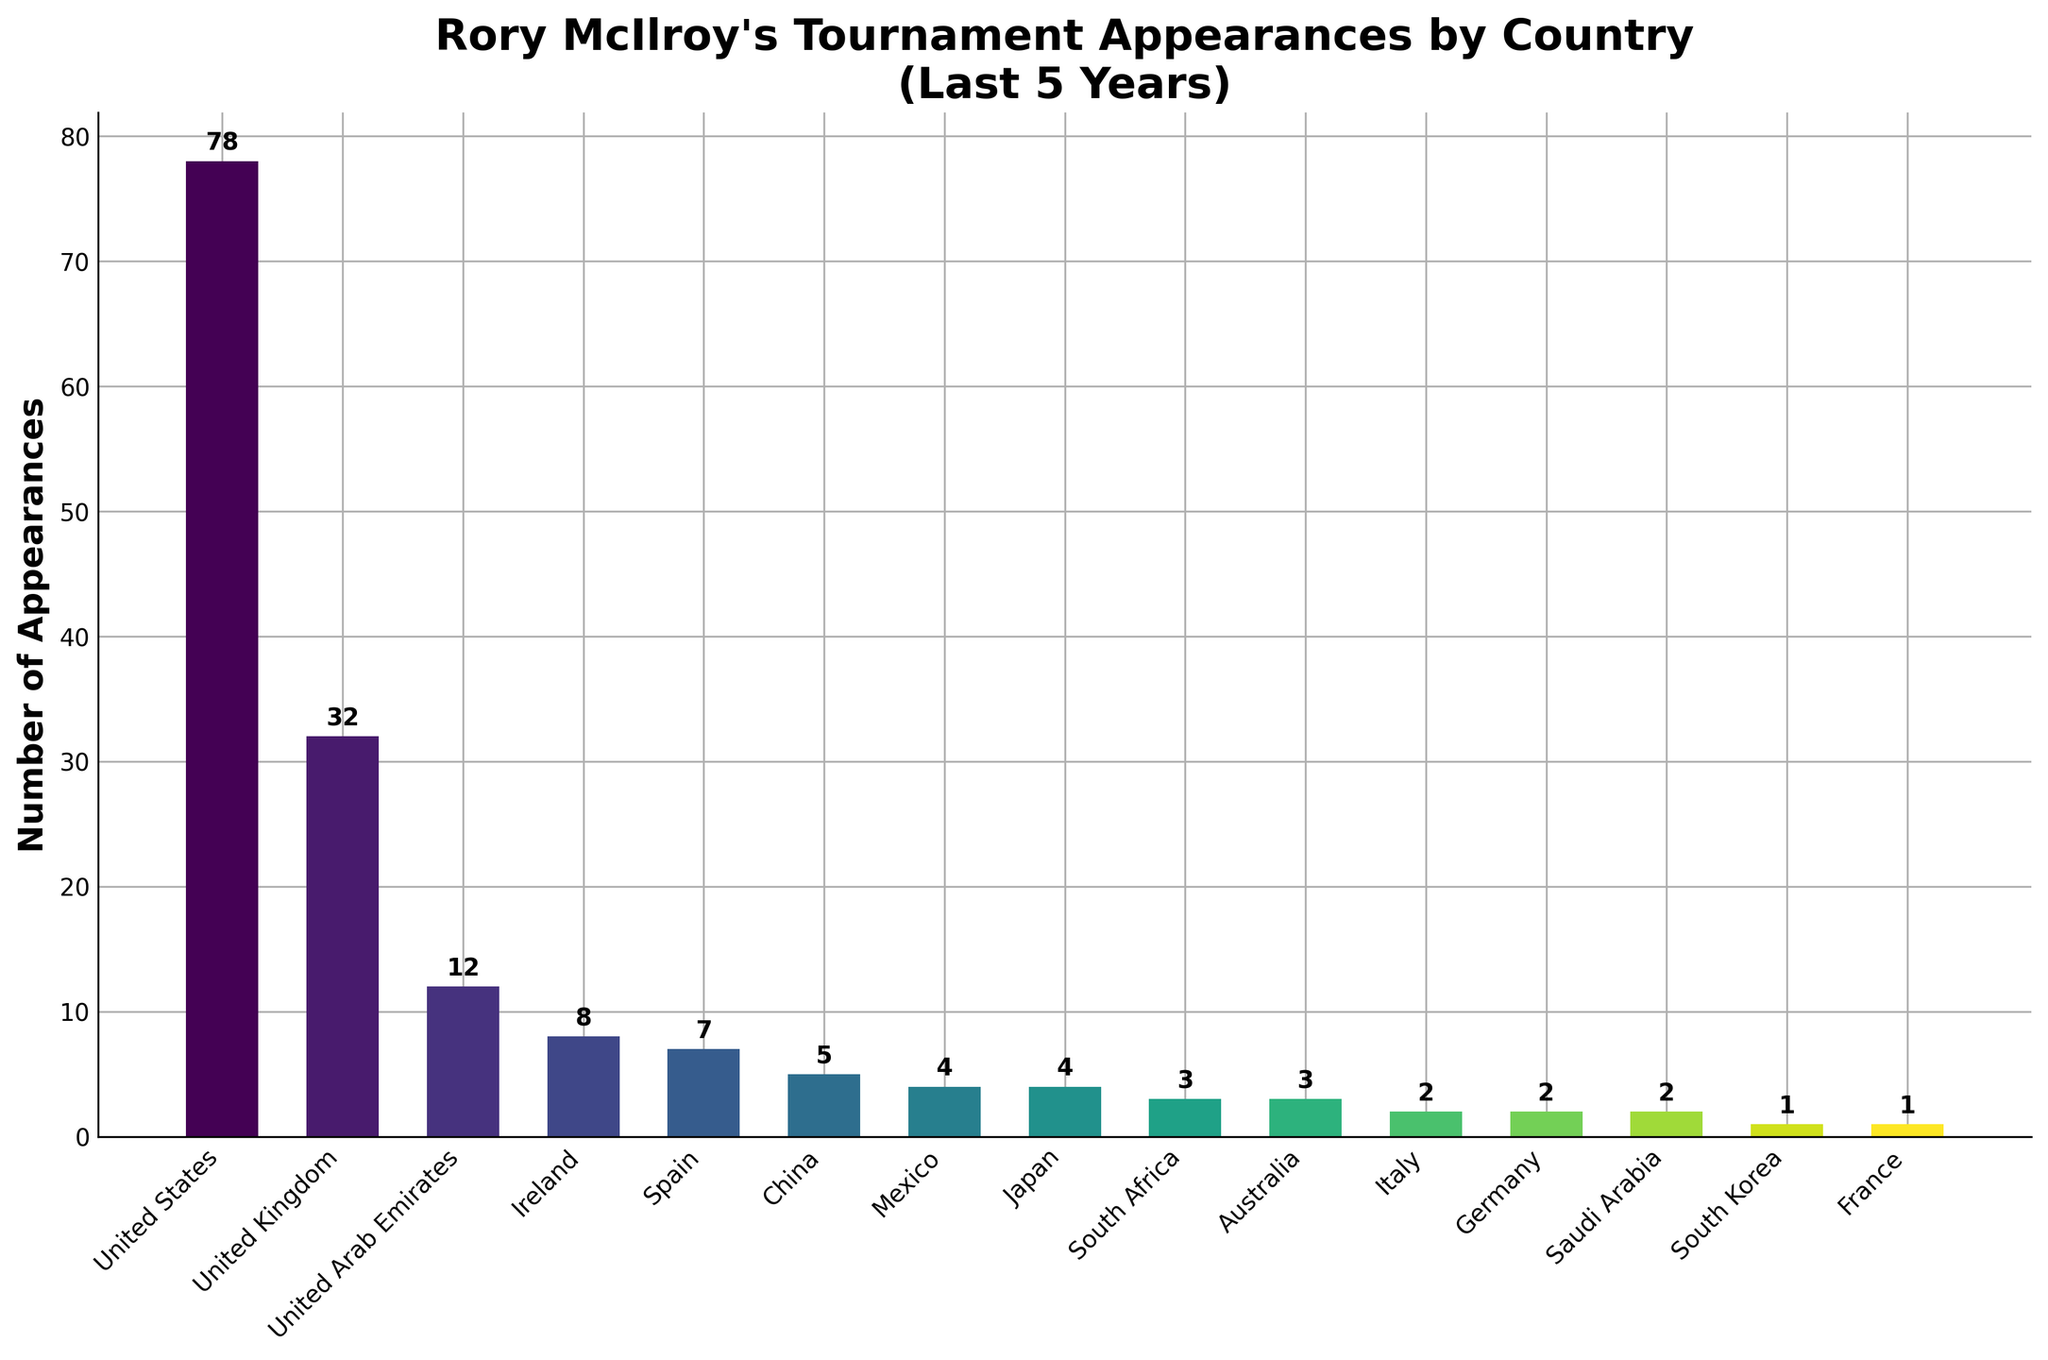Which country has the most tournament appearances by Rory McIlroy? The bar representing the United States is the tallest among all bars in the chart, indicating the highest number of appearances.
Answer: United States How many more appearances does Rory McIlroy have in the United Kingdom compared to Ireland? The figure shows 32 appearances in the United Kingdom and 8 in Ireland. Subtracting these gives 32 - 8 = 24.
Answer: 24 What is the combined total of appearances in Germany and Italy? The bar chart indicates 2 appearances in Germany and 2 in Italy. Summing these values gives us 2 + 2 = 4.
Answer: 4 What is the average number of appearances in the top 3 countries? The top 3 countries are United States (78), United Kingdom (32), and United Arab Emirates (12). Summing these values gives 78 + 32 + 12 = 122. Dividing this by 3 gives 122 / 3 ≈ 40.67.
Answer: 40.67 Which two countries have the same number of appearances, and how many appearances do they each have? By examining the heights of the bars, Japan and Mexico both have the same bar height, corresponding to 4 appearances each.
Answer: Japan and Mexico, 4 How many total tournament appearances has Rory McIlroy made in countries with appearances less than 5? Summing the appearances in China (5), Mexico (4), Japan (4), South Africa (3), Australia (3), Italy (2), Germany (2), Saudi Arabia (2), South Korea (1), and France (1) gives 4 + 4 + 3 + 3 + 2 + 2 + 2 + 1 + 1 = 22.
Answer: 22 How many appearances does Rory McIlroy have in countries outside the top 5? The top 5 countries are United States (78), United Kingdom (32), United Arab Emirates (12), Ireland (8), and Spain (7). The total appearances in these countries sum to 78 + 32 + 12 + 8 + 7 = 137. The total number of appearances listed in the figure is 166. Subtracting the top 5 appearances from the total provides 166 - 137 = 29.
Answer: 29 Which country has the lowest number of appearances, and how many appearances are there? Observing the shortest bars in the chart, South Korea and France both have the lowest bar height corresponding to 1 appearance each.
Answer: South Korea and France, 1 If Rory McIlroy doubles his appearances in Spain, how many total appearances would he have had in Spain? Currently, Rory McIlroy has 7 appearances in Spain. Doubling this total would give 7 * 2 = 14.
Answer: 14 